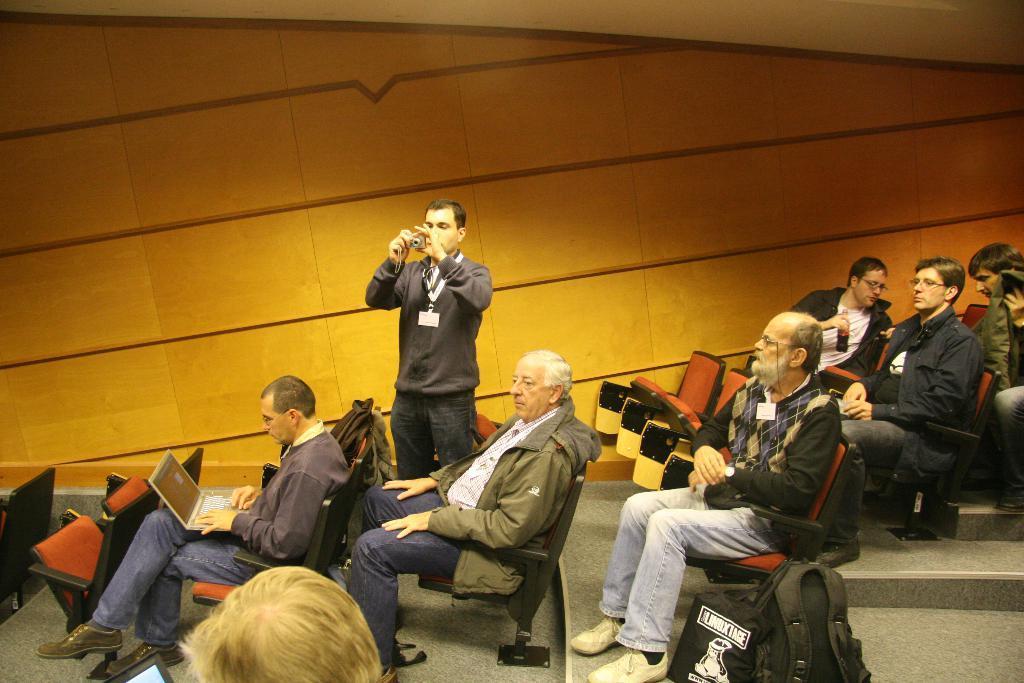Please provide a concise description of this image. In this image in the center there are some people who are sitting on chairs, and one person is holding a bottle and one person is holding a laptop and typing something in a laptop. And in the center there is one person who is standing, and he is holding a camera. At the bottom there are some bags and one person, in the background there is a wall. 